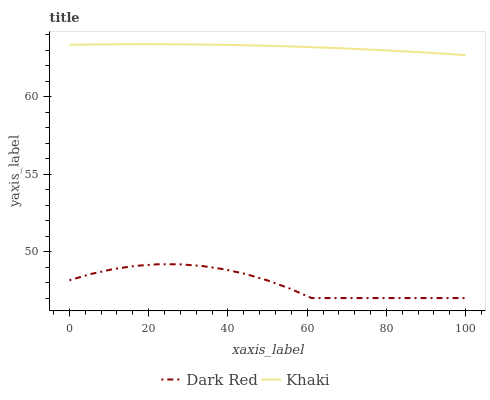Does Khaki have the minimum area under the curve?
Answer yes or no. No. Is Khaki the roughest?
Answer yes or no. No. Does Khaki have the lowest value?
Answer yes or no. No. Is Dark Red less than Khaki?
Answer yes or no. Yes. Is Khaki greater than Dark Red?
Answer yes or no. Yes. Does Dark Red intersect Khaki?
Answer yes or no. No. 